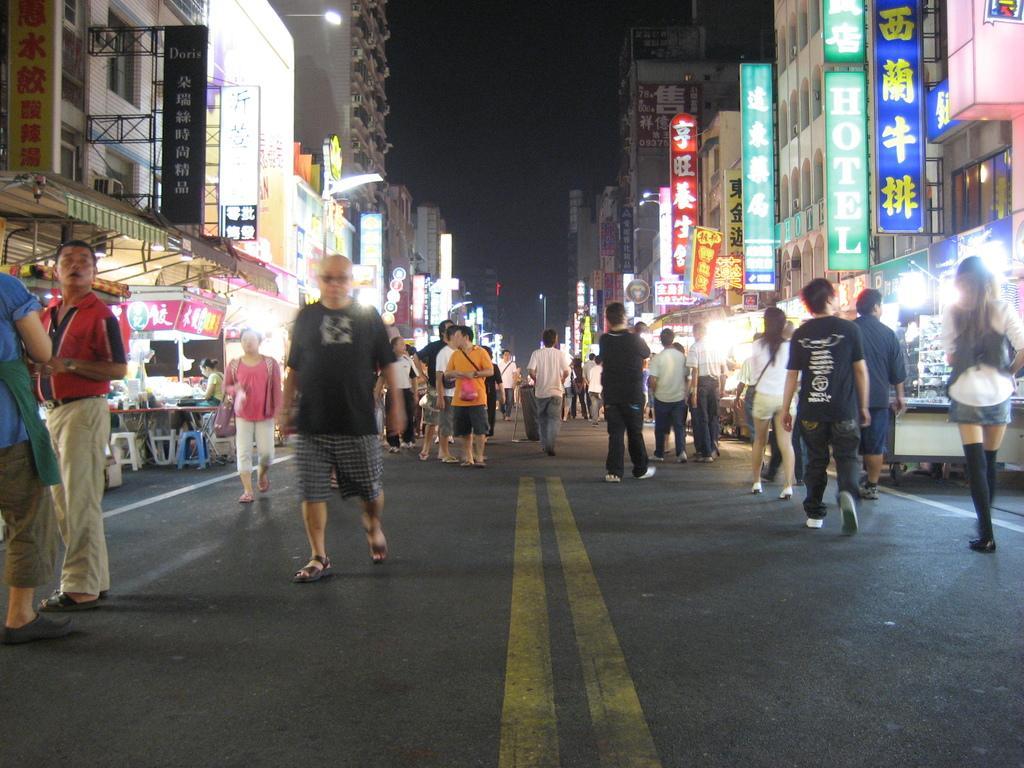Describe this image in one or two sentences. In this image there are group of people standing on the road, and there are chairs, table, buildings, light boards , and in the background there is sky. 